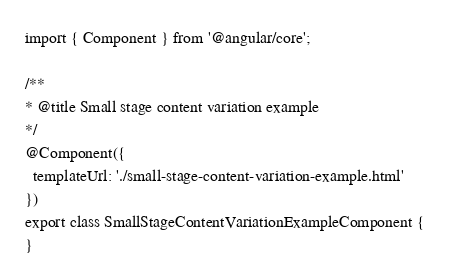<code> <loc_0><loc_0><loc_500><loc_500><_TypeScript_>import { Component } from '@angular/core';

/**
* @title Small stage content variation example
*/
@Component({
  templateUrl: './small-stage-content-variation-example.html'
})
export class SmallStageContentVariationExampleComponent {
}
</code> 